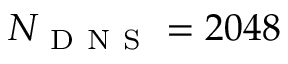<formula> <loc_0><loc_0><loc_500><loc_500>N _ { D N S } = 2 0 4 8</formula> 